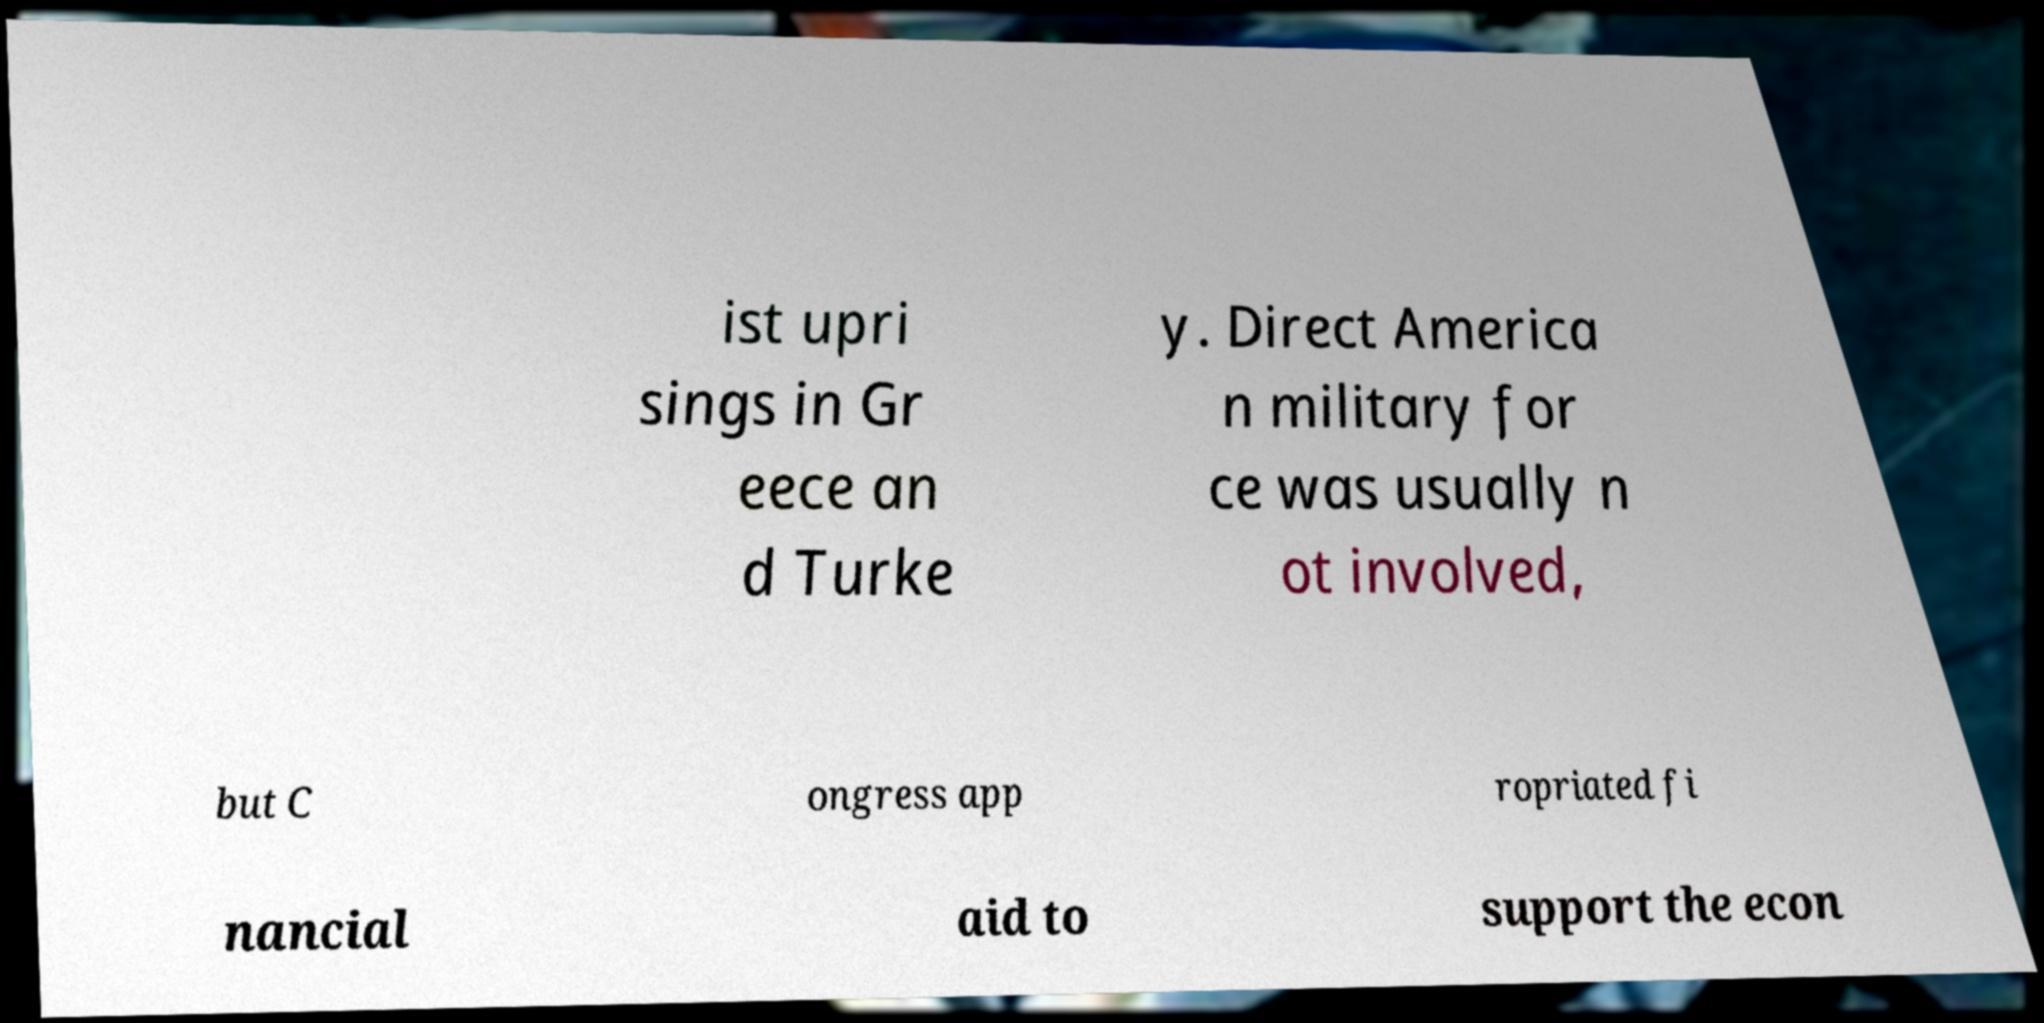Could you extract and type out the text from this image? ist upri sings in Gr eece an d Turke y. Direct America n military for ce was usually n ot involved, but C ongress app ropriated fi nancial aid to support the econ 